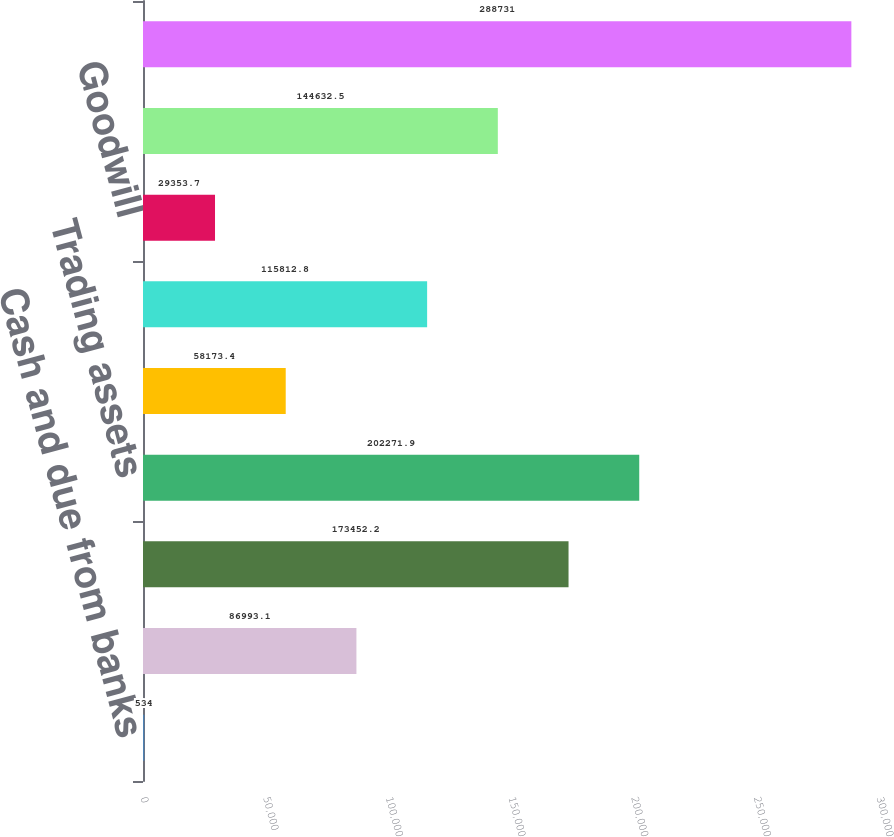Convert chart. <chart><loc_0><loc_0><loc_500><loc_500><bar_chart><fcel>Cash and due from banks<fcel>Federal funds sold and<fcel>Securities borrowed<fcel>Trading assets<fcel>Loans<fcel>Accrued interest and accounts<fcel>Goodwill<fcel>All other assets<fcel>Total assets<nl><fcel>534<fcel>86993.1<fcel>173452<fcel>202272<fcel>58173.4<fcel>115813<fcel>29353.7<fcel>144632<fcel>288731<nl></chart> 